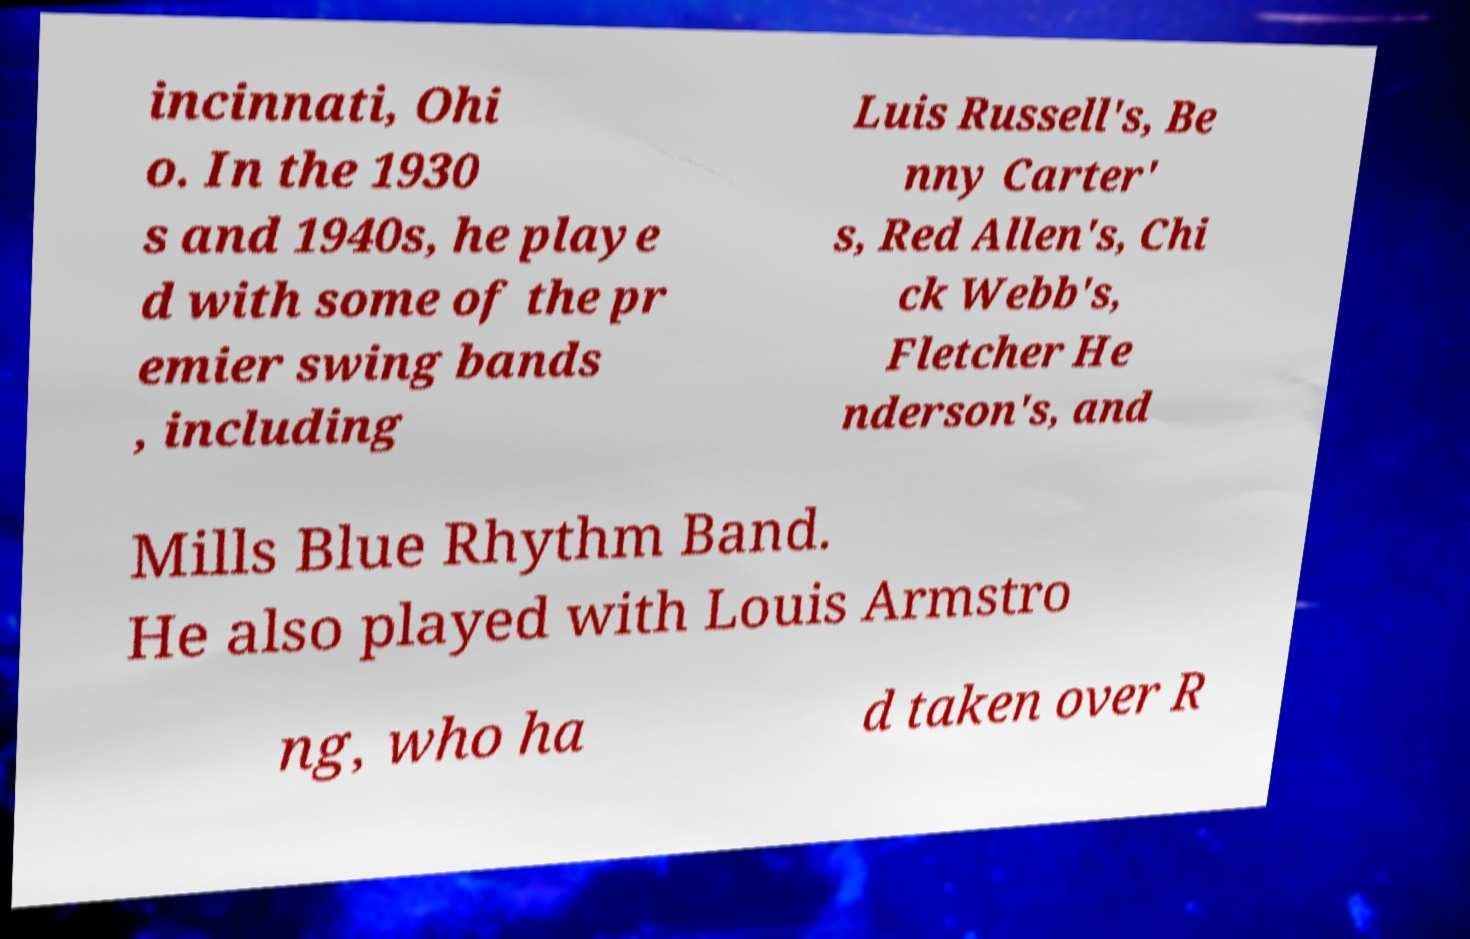There's text embedded in this image that I need extracted. Can you transcribe it verbatim? incinnati, Ohi o. In the 1930 s and 1940s, he playe d with some of the pr emier swing bands , including Luis Russell's, Be nny Carter' s, Red Allen's, Chi ck Webb's, Fletcher He nderson's, and Mills Blue Rhythm Band. He also played with Louis Armstro ng, who ha d taken over R 